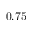Convert formula to latex. <formula><loc_0><loc_0><loc_500><loc_500>0 . 7 5</formula> 